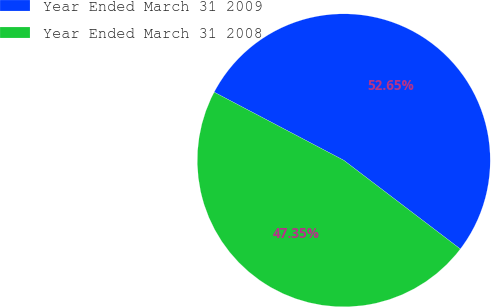Convert chart. <chart><loc_0><loc_0><loc_500><loc_500><pie_chart><fcel>Year Ended March 31 2009<fcel>Year Ended March 31 2008<nl><fcel>52.65%<fcel>47.35%<nl></chart> 